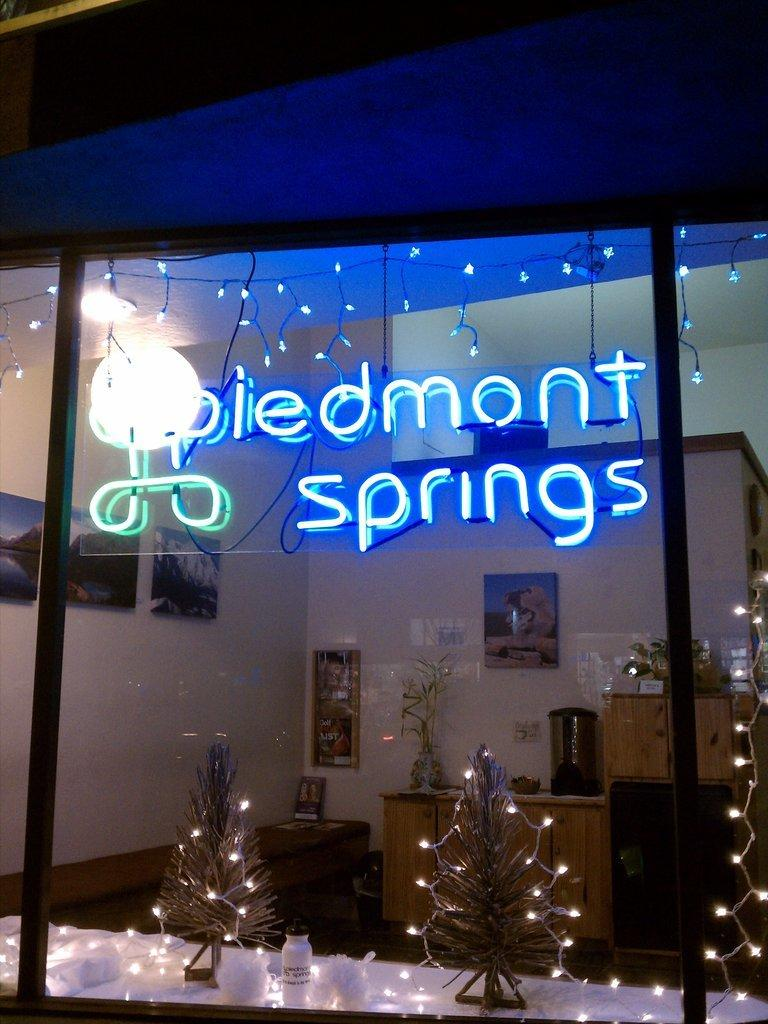What can be seen in the image that provides illumination? There are lights in the image. What type of structure is present in the image? There is a wall in the image. What is hanging on the wall in the image? A: There are photo frames on the wall. How many spiders are crawling on the photo frames in the image? There are no spiders present in the image; it only features lights, a wall, and photo frames. What type of coach is visible in the image? There is no coach present in the image. 